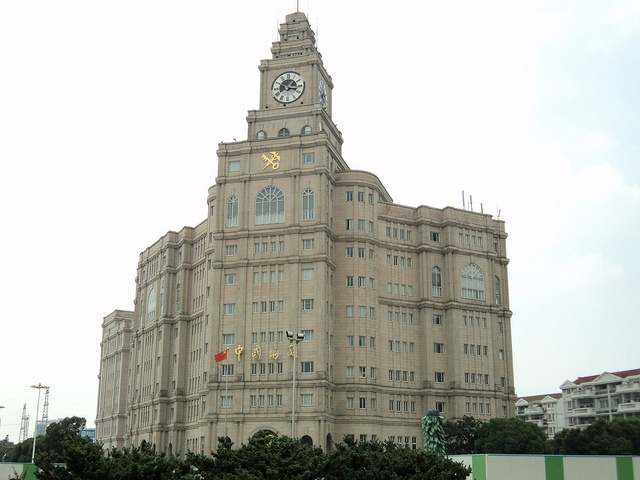Describe the objects in this image and their specific colors. I can see clock in white, darkgray, gray, and lightgray tones and clock in white, darkgray, gray, and lightgray tones in this image. 